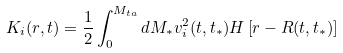Convert formula to latex. <formula><loc_0><loc_0><loc_500><loc_500>K _ { i } ( r , t ) = \frac { 1 } { 2 } \int ^ { M _ { t a } } _ { 0 } d M _ { * } v ^ { 2 } _ { i } ( t , t _ { * } ) H \left [ r - R ( t , t _ { * } ) \right ]</formula> 